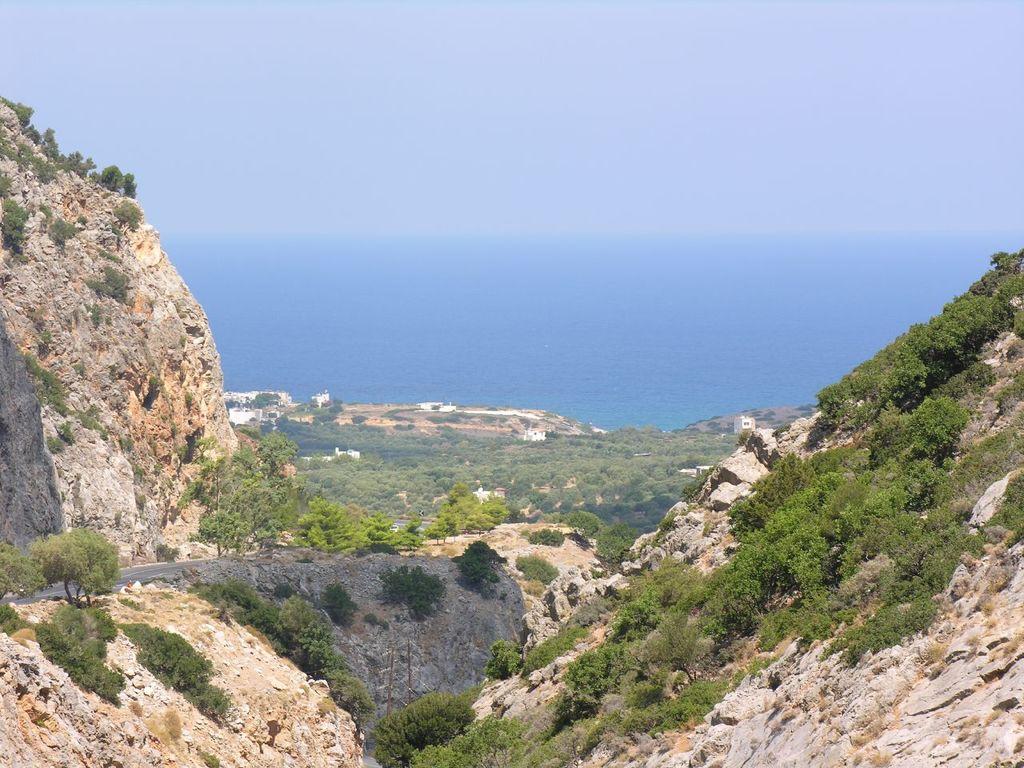In one or two sentences, can you explain what this image depicts? In this image in the front there are rocks and there are plants. In the background there are trees and there is an ocean. 